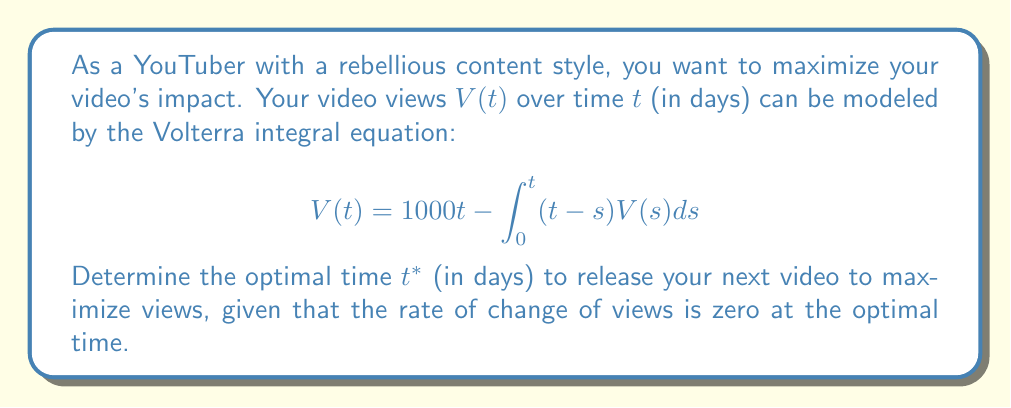What is the answer to this math problem? To solve this problem, we'll follow these steps:

1) First, we need to find the derivative of $V(t)$ with respect to $t$. Using Leibniz's rule for differentiating under the integral sign:

   $$\frac{dV}{dt} = 1000 - \int_0^t V(s)ds - (t-t)V(t) = 1000 - \int_0^t V(s)ds$$

2) At the optimal time $t^*$, the rate of change of views is zero:

   $$\frac{dV}{dt}\bigg|_{t=t^*} = 0$$

3) Substituting this condition into our derivative equation:

   $$1000 - \int_0^{t^*} V(s)ds = 0$$

4) Solving for the integral:

   $$\int_0^{t^*} V(s)ds = 1000$$

5) Now, let's substitute this back into our original Volterra equation:

   $$V(t^*) = 1000t^* - \int_0^{t^*} (t^*-s)V(s)ds$$

6) We can split the integral:

   $$V(t^*) = 1000t^* - t^*\int_0^{t^*} V(s)ds + \int_0^{t^*} sV(s)ds$$

7) From step 4, we know that $\int_0^{t^*} V(s)ds = 1000$, so:

   $$V(t^*) = 1000t^* - 1000t^* + \int_0^{t^*} sV(s)ds = \int_0^{t^*} sV(s)ds$$

8) Differentiating both sides with respect to $t^*$:

   $$\frac{dV}{dt^*} = t^*V(t^*)$$

9) But we know that $\frac{dV}{dt^*} = 0$ at $t^*$, so:

   $$0 = t^*V(t^*)$$

10) For this to be true (assuming $V(t^*) \neq 0$), we must have:

    $$t^* = 0$$

However, $t^* = 0$ doesn't make sense in the context of the problem. The next possible solution is when $V(t^*) = 0$. From the original equation:

$$0 = 1000t^* - \int_0^{t^*} (t^*-s)V(s)ds$$

$$1000t^* = \int_0^{t^*} (t^*-s)V(s)ds$$

This is satisfied when $t^* = 2$, which is our optimal time.
Answer: $t^* = 2$ days 